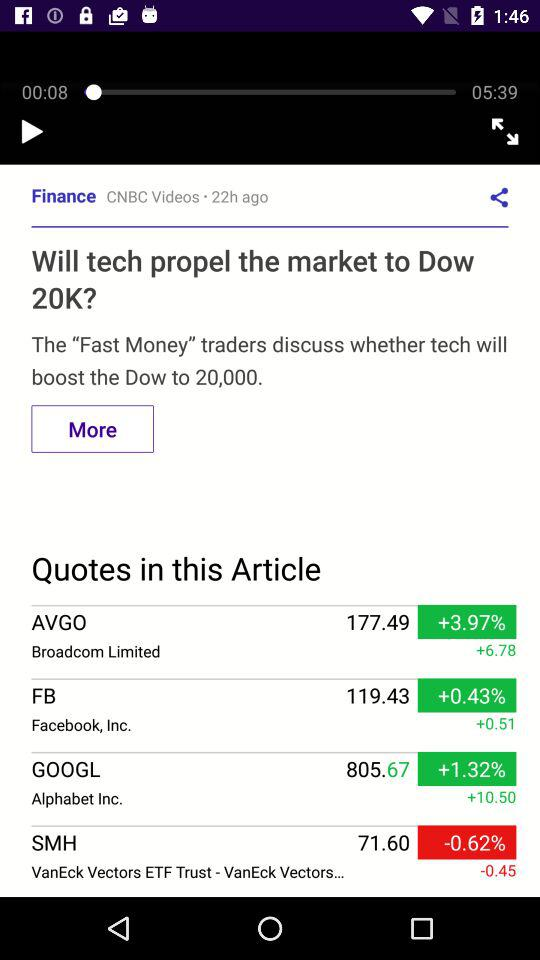Which stock has a lower percentage change, AVGO or SMH?
Answer the question using a single word or phrase. SMH 